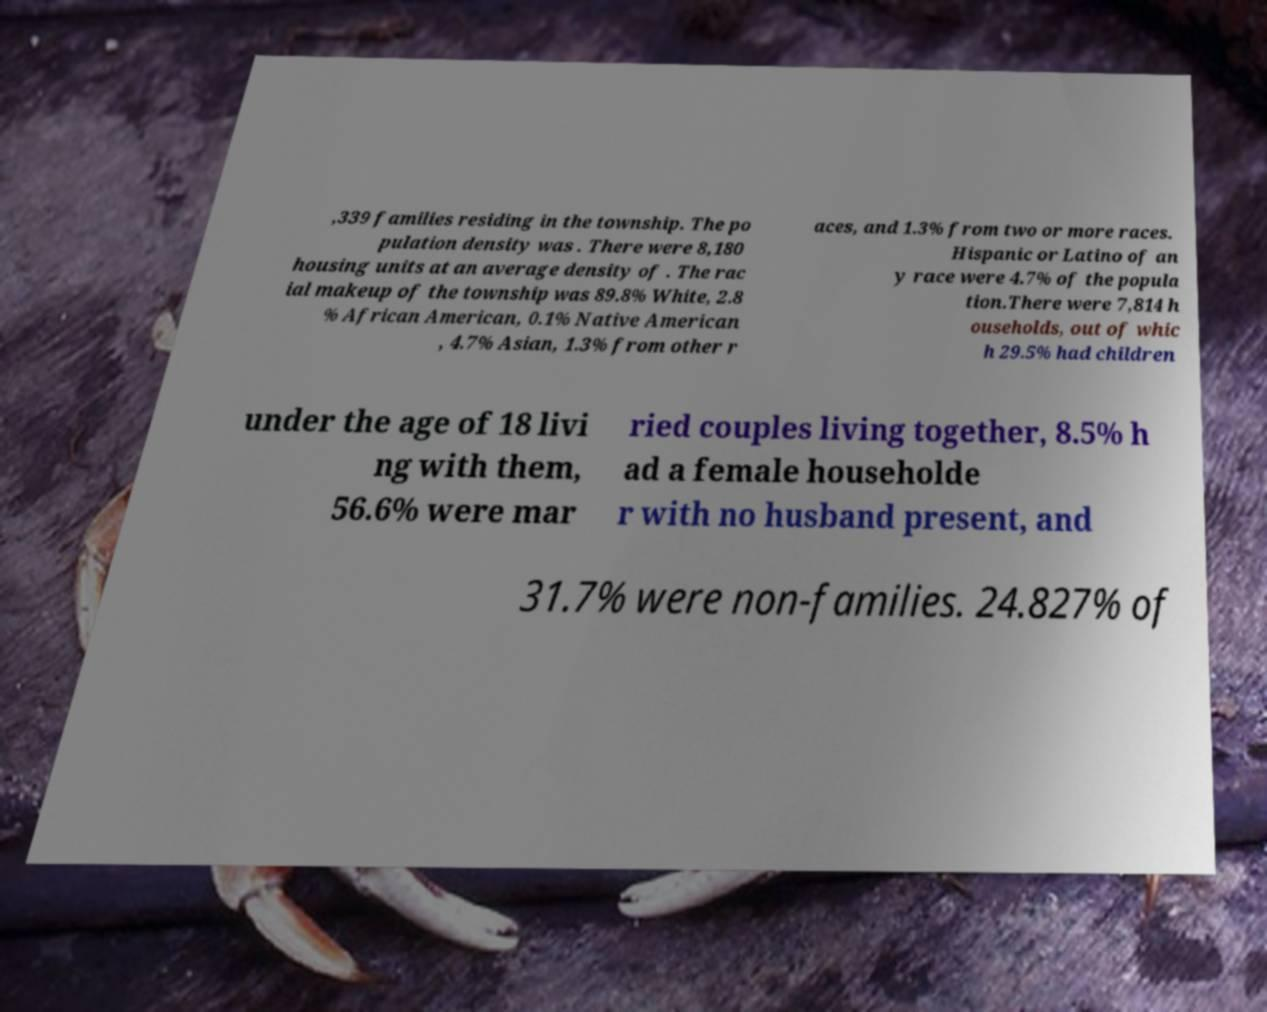Can you read and provide the text displayed in the image?This photo seems to have some interesting text. Can you extract and type it out for me? ,339 families residing in the township. The po pulation density was . There were 8,180 housing units at an average density of . The rac ial makeup of the township was 89.8% White, 2.8 % African American, 0.1% Native American , 4.7% Asian, 1.3% from other r aces, and 1.3% from two or more races. Hispanic or Latino of an y race were 4.7% of the popula tion.There were 7,814 h ouseholds, out of whic h 29.5% had children under the age of 18 livi ng with them, 56.6% were mar ried couples living together, 8.5% h ad a female householde r with no husband present, and 31.7% were non-families. 24.827% of 